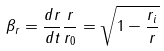<formula> <loc_0><loc_0><loc_500><loc_500>\beta _ { r } = \frac { d r } { d t } \frac { r } { r _ { 0 } } = \sqrt { 1 - \frac { r _ { i } } { r } }</formula> 